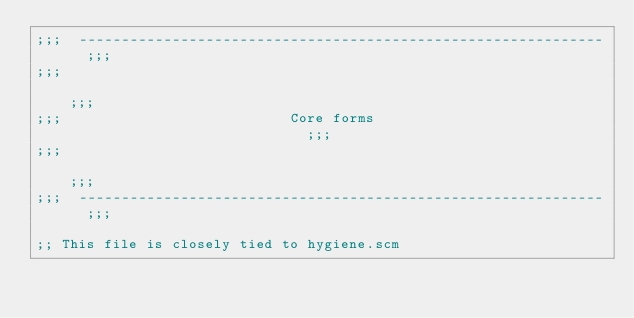Convert code to text. <code><loc_0><loc_0><loc_500><loc_500><_Scheme_>;;;  --------------------------------------------------------------  ;;;
;;;                                                                  ;;;
;;;                           Core forms                             ;;;
;;;                                                                  ;;;
;;;  --------------------------------------------------------------  ;;;

;; This file is closely tied to hygiene.scm
</code> 